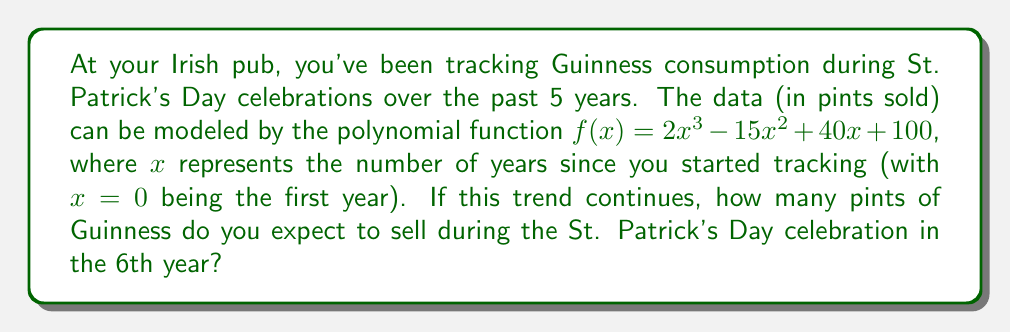Give your solution to this math problem. Let's approach this step-by-step:

1) We're given the polynomial function: $f(x) = 2x^3 - 15x^2 + 40x + 100$

2) We need to find $f(5)$, as the 6th year corresponds to $x = 5$ (remember, we started at $x = 0$)

3) Let's substitute $x = 5$ into the function:

   $f(5) = 2(5)^3 - 15(5)^2 + 40(5) + 100$

4) Now, let's calculate each term:
   - $2(5)^3 = 2(125) = 250$
   - $15(5)^2 = 15(25) = 375$
   - $40(5) = 200$
   - The constant term is already 100

5) Putting it all together:

   $f(5) = 250 - 375 + 200 + 100$

6) Simplifying:

   $f(5) = 175$

Therefore, based on this polynomial regression model, you can expect to sell 175 pints of Guinness during the St. Patrick's Day celebration in the 6th year.
Answer: 175 pints 